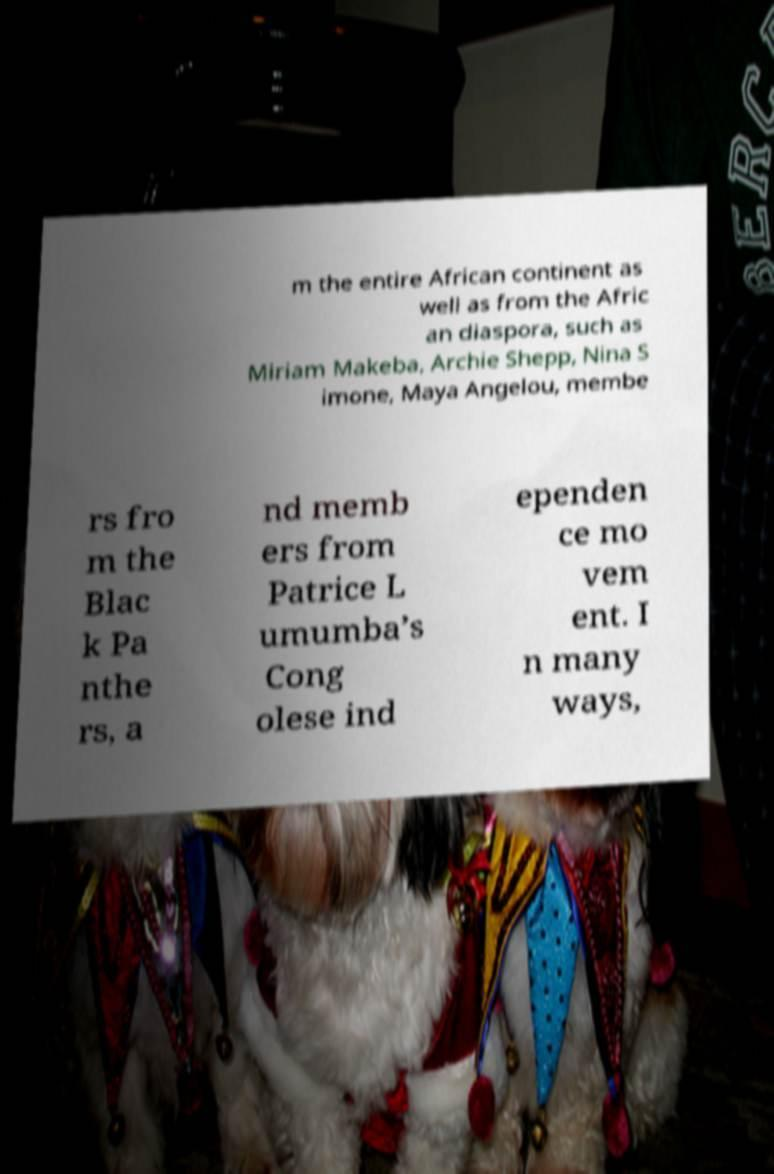Please read and relay the text visible in this image. What does it say? m the entire African continent as well as from the Afric an diaspora, such as Miriam Makeba, Archie Shepp, Nina S imone, Maya Angelou, membe rs fro m the Blac k Pa nthe rs, a nd memb ers from Patrice L umumba’s Cong olese ind ependen ce mo vem ent. I n many ways, 